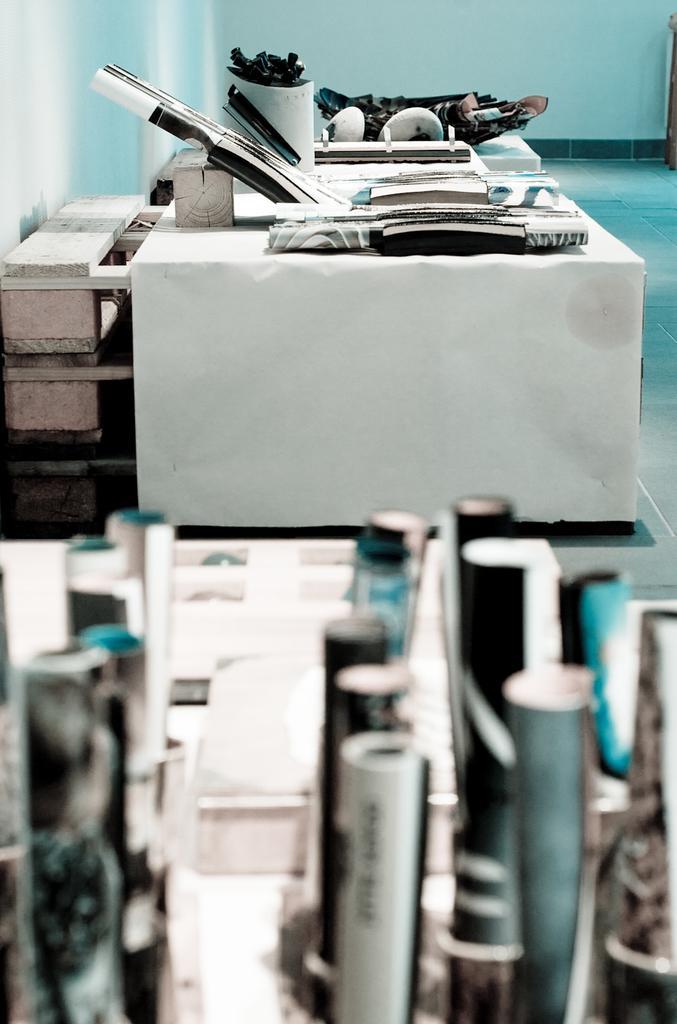How would you summarize this image in a sentence or two? In the center of the image there are tables and we can see papers, boxes and some things placed on the table. In the background there is a wall. 